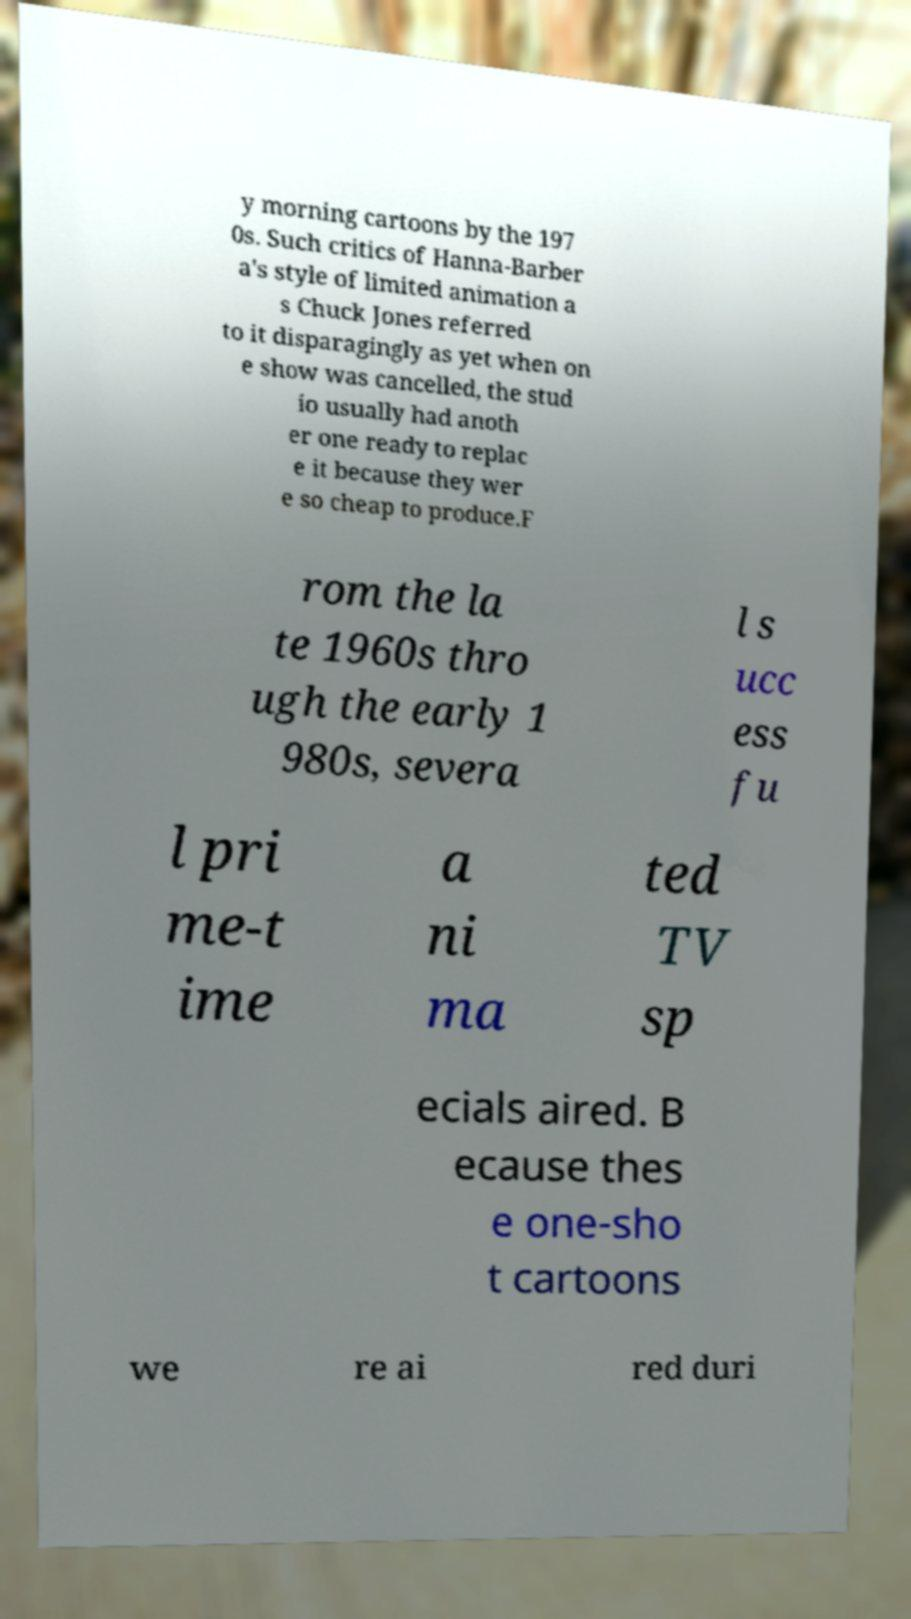Please read and relay the text visible in this image. What does it say? y morning cartoons by the 197 0s. Such critics of Hanna-Barber a's style of limited animation a s Chuck Jones referred to it disparagingly as yet when on e show was cancelled, the stud io usually had anoth er one ready to replac e it because they wer e so cheap to produce.F rom the la te 1960s thro ugh the early 1 980s, severa l s ucc ess fu l pri me-t ime a ni ma ted TV sp ecials aired. B ecause thes e one-sho t cartoons we re ai red duri 